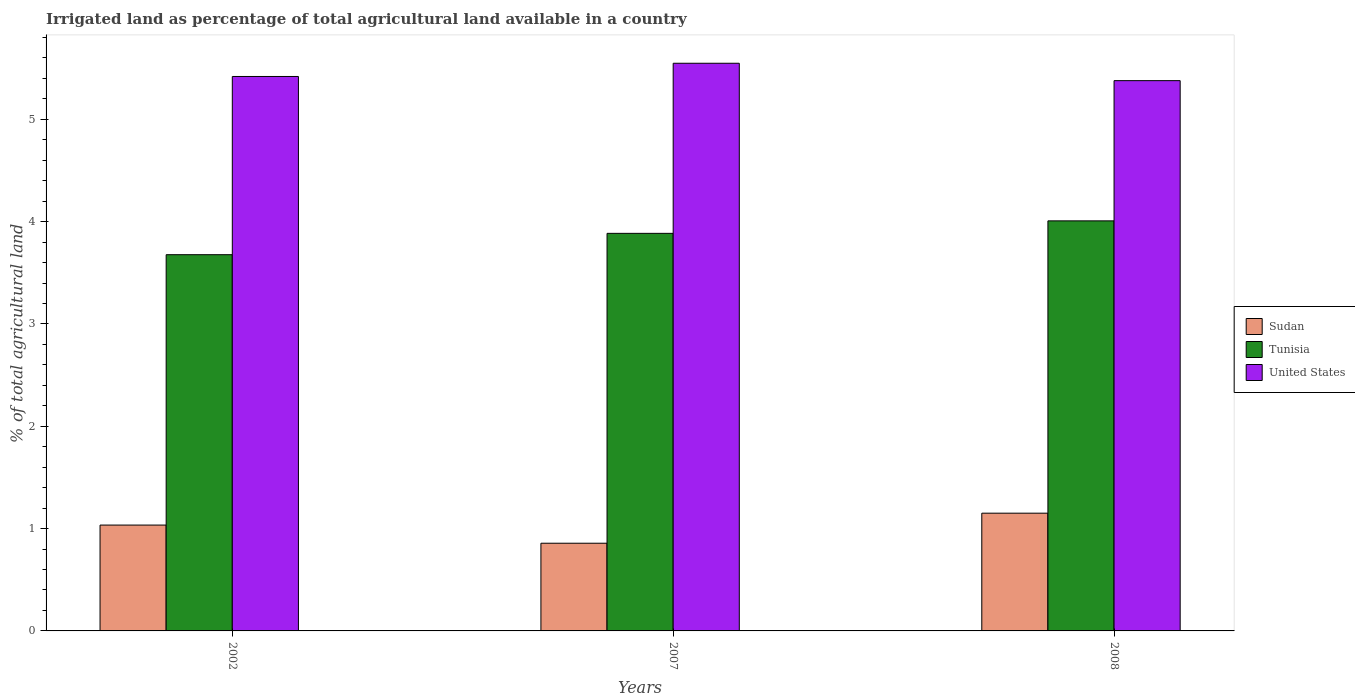How many different coloured bars are there?
Provide a short and direct response. 3. How many groups of bars are there?
Your answer should be compact. 3. How many bars are there on the 2nd tick from the left?
Ensure brevity in your answer.  3. How many bars are there on the 1st tick from the right?
Offer a very short reply. 3. What is the label of the 2nd group of bars from the left?
Offer a terse response. 2007. What is the percentage of irrigated land in Tunisia in 2008?
Your response must be concise. 4.01. Across all years, what is the maximum percentage of irrigated land in Sudan?
Make the answer very short. 1.15. Across all years, what is the minimum percentage of irrigated land in Tunisia?
Ensure brevity in your answer.  3.68. In which year was the percentage of irrigated land in Tunisia maximum?
Give a very brief answer. 2008. In which year was the percentage of irrigated land in Sudan minimum?
Ensure brevity in your answer.  2007. What is the total percentage of irrigated land in Tunisia in the graph?
Offer a terse response. 11.57. What is the difference between the percentage of irrigated land in United States in 2002 and that in 2008?
Give a very brief answer. 0.04. What is the difference between the percentage of irrigated land in Sudan in 2008 and the percentage of irrigated land in Tunisia in 2007?
Give a very brief answer. -2.74. What is the average percentage of irrigated land in Tunisia per year?
Give a very brief answer. 3.86. In the year 2002, what is the difference between the percentage of irrigated land in Tunisia and percentage of irrigated land in United States?
Offer a very short reply. -1.74. What is the ratio of the percentage of irrigated land in Sudan in 2007 to that in 2008?
Your response must be concise. 0.74. Is the difference between the percentage of irrigated land in Tunisia in 2002 and 2008 greater than the difference between the percentage of irrigated land in United States in 2002 and 2008?
Your response must be concise. No. What is the difference between the highest and the second highest percentage of irrigated land in Sudan?
Your response must be concise. 0.12. What is the difference between the highest and the lowest percentage of irrigated land in Sudan?
Offer a terse response. 0.29. In how many years, is the percentage of irrigated land in Tunisia greater than the average percentage of irrigated land in Tunisia taken over all years?
Keep it short and to the point. 2. What does the 2nd bar from the right in 2008 represents?
Offer a terse response. Tunisia. Are all the bars in the graph horizontal?
Your answer should be very brief. No. Are the values on the major ticks of Y-axis written in scientific E-notation?
Provide a succinct answer. No. Does the graph contain any zero values?
Your response must be concise. No. Does the graph contain grids?
Ensure brevity in your answer.  No. How are the legend labels stacked?
Provide a short and direct response. Vertical. What is the title of the graph?
Your answer should be very brief. Irrigated land as percentage of total agricultural land available in a country. Does "Euro area" appear as one of the legend labels in the graph?
Ensure brevity in your answer.  No. What is the label or title of the Y-axis?
Ensure brevity in your answer.  % of total agricultural land. What is the % of total agricultural land of Sudan in 2002?
Offer a very short reply. 1.03. What is the % of total agricultural land of Tunisia in 2002?
Provide a short and direct response. 3.68. What is the % of total agricultural land in United States in 2002?
Your response must be concise. 5.42. What is the % of total agricultural land of Sudan in 2007?
Give a very brief answer. 0.86. What is the % of total agricultural land of Tunisia in 2007?
Offer a very short reply. 3.89. What is the % of total agricultural land in United States in 2007?
Offer a very short reply. 5.55. What is the % of total agricultural land in Sudan in 2008?
Your answer should be very brief. 1.15. What is the % of total agricultural land of Tunisia in 2008?
Offer a very short reply. 4.01. What is the % of total agricultural land in United States in 2008?
Give a very brief answer. 5.38. Across all years, what is the maximum % of total agricultural land of Sudan?
Offer a very short reply. 1.15. Across all years, what is the maximum % of total agricultural land in Tunisia?
Your answer should be compact. 4.01. Across all years, what is the maximum % of total agricultural land of United States?
Offer a terse response. 5.55. Across all years, what is the minimum % of total agricultural land in Sudan?
Provide a short and direct response. 0.86. Across all years, what is the minimum % of total agricultural land of Tunisia?
Offer a very short reply. 3.68. Across all years, what is the minimum % of total agricultural land of United States?
Keep it short and to the point. 5.38. What is the total % of total agricultural land in Sudan in the graph?
Provide a succinct answer. 3.04. What is the total % of total agricultural land of Tunisia in the graph?
Your answer should be compact. 11.57. What is the total % of total agricultural land in United States in the graph?
Give a very brief answer. 16.35. What is the difference between the % of total agricultural land in Sudan in 2002 and that in 2007?
Give a very brief answer. 0.18. What is the difference between the % of total agricultural land in Tunisia in 2002 and that in 2007?
Offer a very short reply. -0.21. What is the difference between the % of total agricultural land of United States in 2002 and that in 2007?
Offer a very short reply. -0.13. What is the difference between the % of total agricultural land in Sudan in 2002 and that in 2008?
Give a very brief answer. -0.12. What is the difference between the % of total agricultural land of Tunisia in 2002 and that in 2008?
Provide a succinct answer. -0.33. What is the difference between the % of total agricultural land in United States in 2002 and that in 2008?
Offer a very short reply. 0.04. What is the difference between the % of total agricultural land in Sudan in 2007 and that in 2008?
Make the answer very short. -0.29. What is the difference between the % of total agricultural land in Tunisia in 2007 and that in 2008?
Ensure brevity in your answer.  -0.12. What is the difference between the % of total agricultural land of United States in 2007 and that in 2008?
Provide a short and direct response. 0.17. What is the difference between the % of total agricultural land of Sudan in 2002 and the % of total agricultural land of Tunisia in 2007?
Give a very brief answer. -2.85. What is the difference between the % of total agricultural land in Sudan in 2002 and the % of total agricultural land in United States in 2007?
Your response must be concise. -4.51. What is the difference between the % of total agricultural land in Tunisia in 2002 and the % of total agricultural land in United States in 2007?
Your answer should be compact. -1.87. What is the difference between the % of total agricultural land in Sudan in 2002 and the % of total agricultural land in Tunisia in 2008?
Your response must be concise. -2.97. What is the difference between the % of total agricultural land of Sudan in 2002 and the % of total agricultural land of United States in 2008?
Your response must be concise. -4.34. What is the difference between the % of total agricultural land in Tunisia in 2002 and the % of total agricultural land in United States in 2008?
Offer a terse response. -1.7. What is the difference between the % of total agricultural land of Sudan in 2007 and the % of total agricultural land of Tunisia in 2008?
Make the answer very short. -3.15. What is the difference between the % of total agricultural land of Sudan in 2007 and the % of total agricultural land of United States in 2008?
Offer a very short reply. -4.52. What is the difference between the % of total agricultural land of Tunisia in 2007 and the % of total agricultural land of United States in 2008?
Make the answer very short. -1.49. What is the average % of total agricultural land of Sudan per year?
Your answer should be very brief. 1.01. What is the average % of total agricultural land in Tunisia per year?
Your answer should be compact. 3.86. What is the average % of total agricultural land in United States per year?
Give a very brief answer. 5.45. In the year 2002, what is the difference between the % of total agricultural land of Sudan and % of total agricultural land of Tunisia?
Keep it short and to the point. -2.64. In the year 2002, what is the difference between the % of total agricultural land of Sudan and % of total agricultural land of United States?
Your response must be concise. -4.38. In the year 2002, what is the difference between the % of total agricultural land of Tunisia and % of total agricultural land of United States?
Provide a short and direct response. -1.74. In the year 2007, what is the difference between the % of total agricultural land of Sudan and % of total agricultural land of Tunisia?
Provide a succinct answer. -3.03. In the year 2007, what is the difference between the % of total agricultural land of Sudan and % of total agricultural land of United States?
Keep it short and to the point. -4.69. In the year 2007, what is the difference between the % of total agricultural land in Tunisia and % of total agricultural land in United States?
Keep it short and to the point. -1.66. In the year 2008, what is the difference between the % of total agricultural land of Sudan and % of total agricultural land of Tunisia?
Offer a terse response. -2.86. In the year 2008, what is the difference between the % of total agricultural land of Sudan and % of total agricultural land of United States?
Your answer should be very brief. -4.23. In the year 2008, what is the difference between the % of total agricultural land of Tunisia and % of total agricultural land of United States?
Offer a very short reply. -1.37. What is the ratio of the % of total agricultural land of Sudan in 2002 to that in 2007?
Provide a short and direct response. 1.21. What is the ratio of the % of total agricultural land in Tunisia in 2002 to that in 2007?
Your response must be concise. 0.95. What is the ratio of the % of total agricultural land in United States in 2002 to that in 2007?
Provide a succinct answer. 0.98. What is the ratio of the % of total agricultural land in Sudan in 2002 to that in 2008?
Ensure brevity in your answer.  0.9. What is the ratio of the % of total agricultural land of Tunisia in 2002 to that in 2008?
Keep it short and to the point. 0.92. What is the ratio of the % of total agricultural land in United States in 2002 to that in 2008?
Make the answer very short. 1.01. What is the ratio of the % of total agricultural land of Sudan in 2007 to that in 2008?
Offer a terse response. 0.74. What is the ratio of the % of total agricultural land in Tunisia in 2007 to that in 2008?
Give a very brief answer. 0.97. What is the ratio of the % of total agricultural land of United States in 2007 to that in 2008?
Give a very brief answer. 1.03. What is the difference between the highest and the second highest % of total agricultural land of Sudan?
Offer a very short reply. 0.12. What is the difference between the highest and the second highest % of total agricultural land in Tunisia?
Offer a terse response. 0.12. What is the difference between the highest and the second highest % of total agricultural land of United States?
Give a very brief answer. 0.13. What is the difference between the highest and the lowest % of total agricultural land of Sudan?
Provide a short and direct response. 0.29. What is the difference between the highest and the lowest % of total agricultural land in Tunisia?
Your answer should be compact. 0.33. What is the difference between the highest and the lowest % of total agricultural land of United States?
Ensure brevity in your answer.  0.17. 